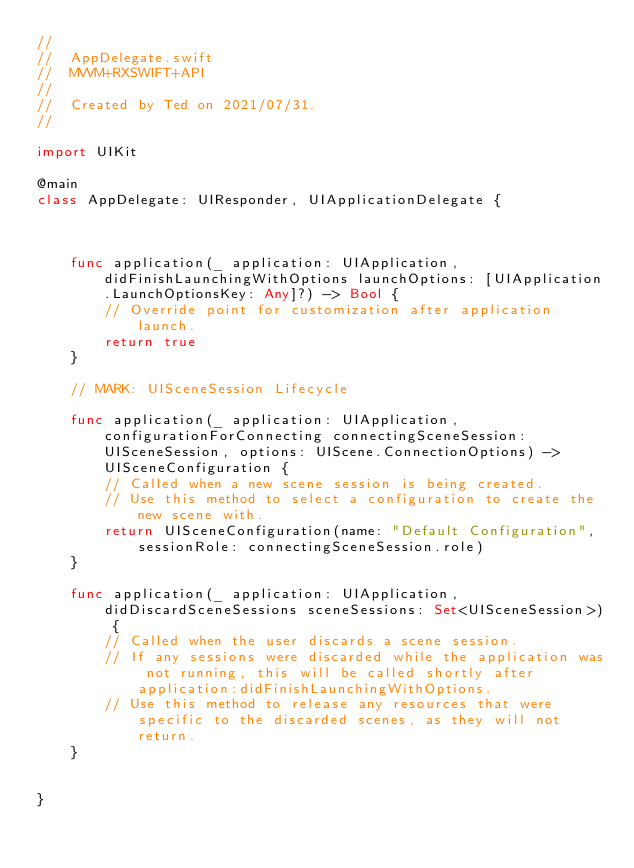<code> <loc_0><loc_0><loc_500><loc_500><_Swift_>//
//  AppDelegate.swift
//  MVVM+RXSWIFT+API
//
//  Created by Ted on 2021/07/31.
//

import UIKit

@main
class AppDelegate: UIResponder, UIApplicationDelegate {



    func application(_ application: UIApplication, didFinishLaunchingWithOptions launchOptions: [UIApplication.LaunchOptionsKey: Any]?) -> Bool {
        // Override point for customization after application launch.
        return true
    }

    // MARK: UISceneSession Lifecycle

    func application(_ application: UIApplication, configurationForConnecting connectingSceneSession: UISceneSession, options: UIScene.ConnectionOptions) -> UISceneConfiguration {
        // Called when a new scene session is being created.
        // Use this method to select a configuration to create the new scene with.
        return UISceneConfiguration(name: "Default Configuration", sessionRole: connectingSceneSession.role)
    }

    func application(_ application: UIApplication, didDiscardSceneSessions sceneSessions: Set<UISceneSession>) {
        // Called when the user discards a scene session.
        // If any sessions were discarded while the application was not running, this will be called shortly after application:didFinishLaunchingWithOptions.
        // Use this method to release any resources that were specific to the discarded scenes, as they will not return.
    }


}

</code> 